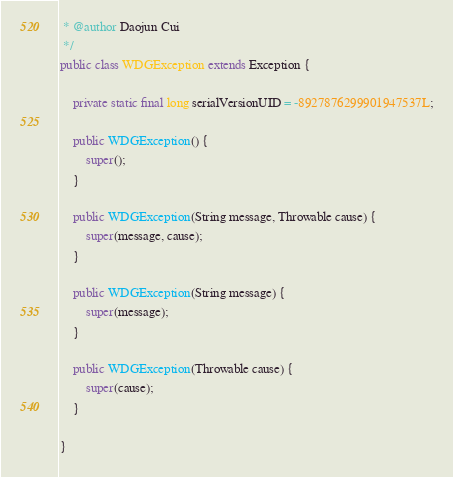<code> <loc_0><loc_0><loc_500><loc_500><_Java_> * @author Daojun Cui
 */
public class WDGException extends Exception {

	private static final long serialVersionUID = -8927876299901947537L;

	public WDGException() {
		super();
	}

	public WDGException(String message, Throwable cause) {
		super(message, cause);
	}

	public WDGException(String message) {
		super(message);
	}

	public WDGException(Throwable cause) {
		super(cause);
	}

}
</code> 